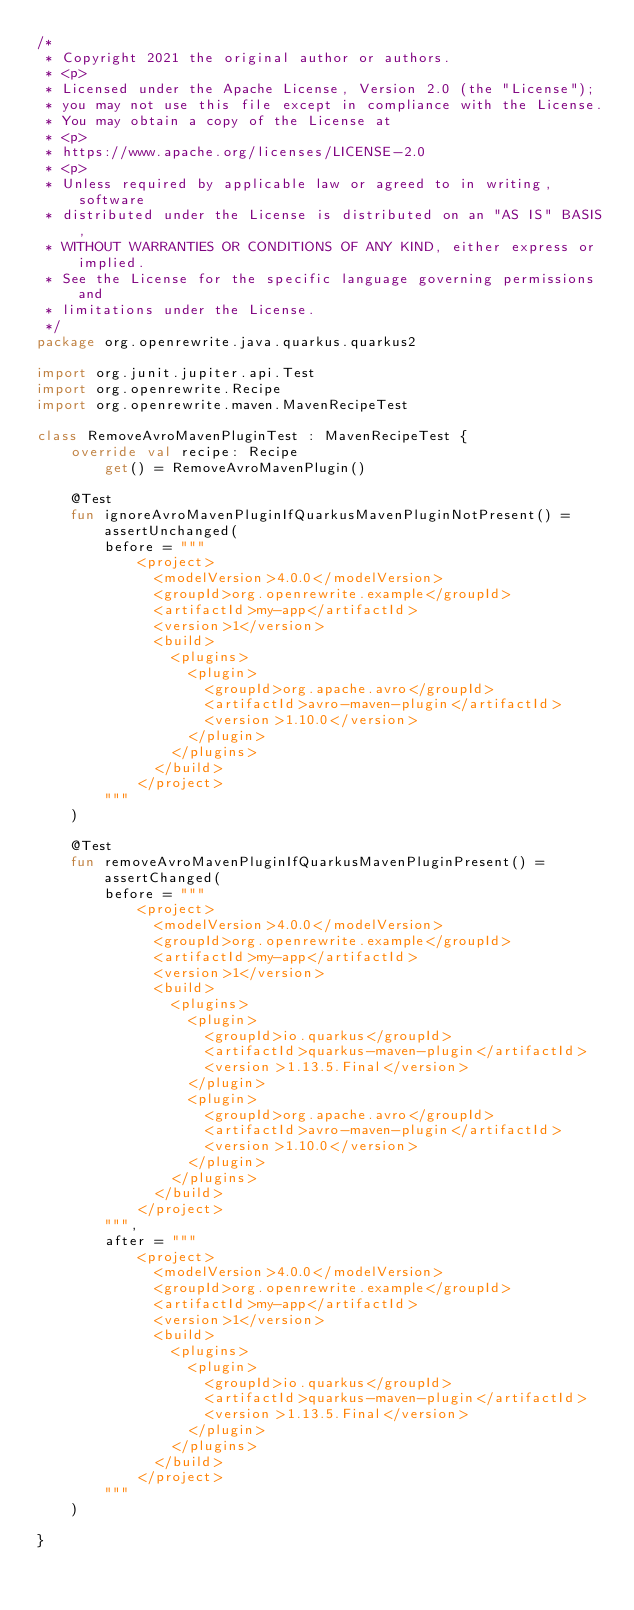Convert code to text. <code><loc_0><loc_0><loc_500><loc_500><_Kotlin_>/*
 * Copyright 2021 the original author or authors.
 * <p>
 * Licensed under the Apache License, Version 2.0 (the "License");
 * you may not use this file except in compliance with the License.
 * You may obtain a copy of the License at
 * <p>
 * https://www.apache.org/licenses/LICENSE-2.0
 * <p>
 * Unless required by applicable law or agreed to in writing, software
 * distributed under the License is distributed on an "AS IS" BASIS,
 * WITHOUT WARRANTIES OR CONDITIONS OF ANY KIND, either express or implied.
 * See the License for the specific language governing permissions and
 * limitations under the License.
 */
package org.openrewrite.java.quarkus.quarkus2

import org.junit.jupiter.api.Test
import org.openrewrite.Recipe
import org.openrewrite.maven.MavenRecipeTest

class RemoveAvroMavenPluginTest : MavenRecipeTest {
    override val recipe: Recipe
        get() = RemoveAvroMavenPlugin()

    @Test
    fun ignoreAvroMavenPluginIfQuarkusMavenPluginNotPresent() = assertUnchanged(
        before = """
            <project>
              <modelVersion>4.0.0</modelVersion>
              <groupId>org.openrewrite.example</groupId>
              <artifactId>my-app</artifactId>
              <version>1</version>
              <build>
                <plugins>
                  <plugin>
                    <groupId>org.apache.avro</groupId>
                    <artifactId>avro-maven-plugin</artifactId>
                    <version>1.10.0</version>
                  </plugin>
                </plugins>
              </build>
            </project>
        """
    )

    @Test
    fun removeAvroMavenPluginIfQuarkusMavenPluginPresent() = assertChanged(
        before = """
            <project>
              <modelVersion>4.0.0</modelVersion>
              <groupId>org.openrewrite.example</groupId>
              <artifactId>my-app</artifactId>
              <version>1</version>
              <build>
                <plugins>
                  <plugin>
                    <groupId>io.quarkus</groupId>
                    <artifactId>quarkus-maven-plugin</artifactId>
                    <version>1.13.5.Final</version>
                  </plugin>
                  <plugin>
                    <groupId>org.apache.avro</groupId>
                    <artifactId>avro-maven-plugin</artifactId>
                    <version>1.10.0</version>
                  </plugin>
                </plugins>
              </build>
            </project>
        """,
        after = """
            <project>
              <modelVersion>4.0.0</modelVersion>
              <groupId>org.openrewrite.example</groupId>
              <artifactId>my-app</artifactId>
              <version>1</version>
              <build>
                <plugins>
                  <plugin>
                    <groupId>io.quarkus</groupId>
                    <artifactId>quarkus-maven-plugin</artifactId>
                    <version>1.13.5.Final</version>
                  </plugin>
                </plugins>
              </build>
            </project>
        """
    )

}</code> 